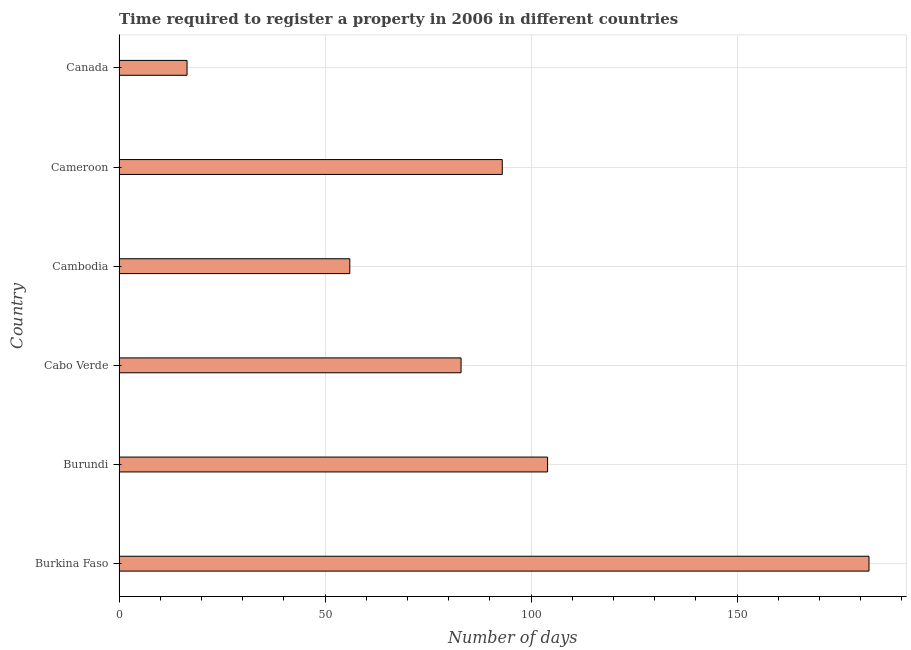What is the title of the graph?
Make the answer very short. Time required to register a property in 2006 in different countries. What is the label or title of the X-axis?
Offer a terse response. Number of days. What is the label or title of the Y-axis?
Offer a terse response. Country. What is the number of days required to register property in Burundi?
Your response must be concise. 104. Across all countries, what is the maximum number of days required to register property?
Give a very brief answer. 182. Across all countries, what is the minimum number of days required to register property?
Make the answer very short. 16.5. In which country was the number of days required to register property maximum?
Your response must be concise. Burkina Faso. In which country was the number of days required to register property minimum?
Offer a terse response. Canada. What is the sum of the number of days required to register property?
Provide a succinct answer. 534.5. What is the difference between the number of days required to register property in Cameroon and Canada?
Keep it short and to the point. 76.5. What is the average number of days required to register property per country?
Provide a succinct answer. 89.08. What is the median number of days required to register property?
Your answer should be compact. 88. What is the ratio of the number of days required to register property in Burkina Faso to that in Cabo Verde?
Make the answer very short. 2.19. What is the difference between the highest and the second highest number of days required to register property?
Your response must be concise. 78. What is the difference between the highest and the lowest number of days required to register property?
Keep it short and to the point. 165.5. In how many countries, is the number of days required to register property greater than the average number of days required to register property taken over all countries?
Your answer should be compact. 3. What is the Number of days of Burkina Faso?
Provide a short and direct response. 182. What is the Number of days in Burundi?
Your response must be concise. 104. What is the Number of days in Cabo Verde?
Your response must be concise. 83. What is the Number of days in Cameroon?
Your answer should be compact. 93. What is the Number of days of Canada?
Provide a succinct answer. 16.5. What is the difference between the Number of days in Burkina Faso and Burundi?
Ensure brevity in your answer.  78. What is the difference between the Number of days in Burkina Faso and Cambodia?
Ensure brevity in your answer.  126. What is the difference between the Number of days in Burkina Faso and Cameroon?
Your answer should be very brief. 89. What is the difference between the Number of days in Burkina Faso and Canada?
Your response must be concise. 165.5. What is the difference between the Number of days in Burundi and Canada?
Your answer should be compact. 87.5. What is the difference between the Number of days in Cabo Verde and Canada?
Give a very brief answer. 66.5. What is the difference between the Number of days in Cambodia and Cameroon?
Keep it short and to the point. -37. What is the difference between the Number of days in Cambodia and Canada?
Ensure brevity in your answer.  39.5. What is the difference between the Number of days in Cameroon and Canada?
Provide a succinct answer. 76.5. What is the ratio of the Number of days in Burkina Faso to that in Cabo Verde?
Offer a terse response. 2.19. What is the ratio of the Number of days in Burkina Faso to that in Cameroon?
Make the answer very short. 1.96. What is the ratio of the Number of days in Burkina Faso to that in Canada?
Ensure brevity in your answer.  11.03. What is the ratio of the Number of days in Burundi to that in Cabo Verde?
Offer a terse response. 1.25. What is the ratio of the Number of days in Burundi to that in Cambodia?
Provide a succinct answer. 1.86. What is the ratio of the Number of days in Burundi to that in Cameroon?
Provide a succinct answer. 1.12. What is the ratio of the Number of days in Burundi to that in Canada?
Provide a succinct answer. 6.3. What is the ratio of the Number of days in Cabo Verde to that in Cambodia?
Your response must be concise. 1.48. What is the ratio of the Number of days in Cabo Verde to that in Cameroon?
Your answer should be very brief. 0.89. What is the ratio of the Number of days in Cabo Verde to that in Canada?
Give a very brief answer. 5.03. What is the ratio of the Number of days in Cambodia to that in Cameroon?
Provide a short and direct response. 0.6. What is the ratio of the Number of days in Cambodia to that in Canada?
Offer a terse response. 3.39. What is the ratio of the Number of days in Cameroon to that in Canada?
Offer a very short reply. 5.64. 